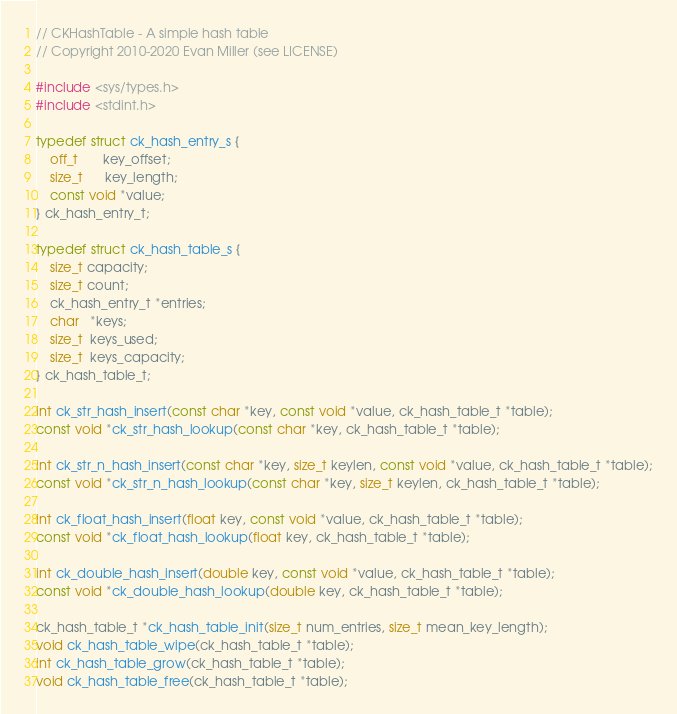Convert code to text. <code><loc_0><loc_0><loc_500><loc_500><_C_>// CKHashTable - A simple hash table
// Copyright 2010-2020 Evan Miller (see LICENSE)

#include <sys/types.h>
#include <stdint.h>

typedef struct ck_hash_entry_s {
    off_t       key_offset;
    size_t      key_length;
	const void *value;
} ck_hash_entry_t;

typedef struct ck_hash_table_s {
    size_t capacity;
    size_t count;
	ck_hash_entry_t *entries;
    char   *keys;
    size_t  keys_used;
    size_t  keys_capacity;
} ck_hash_table_t;

int ck_str_hash_insert(const char *key, const void *value, ck_hash_table_t *table);
const void *ck_str_hash_lookup(const char *key, ck_hash_table_t *table);

int ck_str_n_hash_insert(const char *key, size_t keylen, const void *value, ck_hash_table_t *table);
const void *ck_str_n_hash_lookup(const char *key, size_t keylen, ck_hash_table_t *table);

int ck_float_hash_insert(float key, const void *value, ck_hash_table_t *table);
const void *ck_float_hash_lookup(float key, ck_hash_table_t *table);

int ck_double_hash_insert(double key, const void *value, ck_hash_table_t *table);
const void *ck_double_hash_lookup(double key, ck_hash_table_t *table);

ck_hash_table_t *ck_hash_table_init(size_t num_entries, size_t mean_key_length);
void ck_hash_table_wipe(ck_hash_table_t *table);
int ck_hash_table_grow(ck_hash_table_t *table);
void ck_hash_table_free(ck_hash_table_t *table);
</code> 